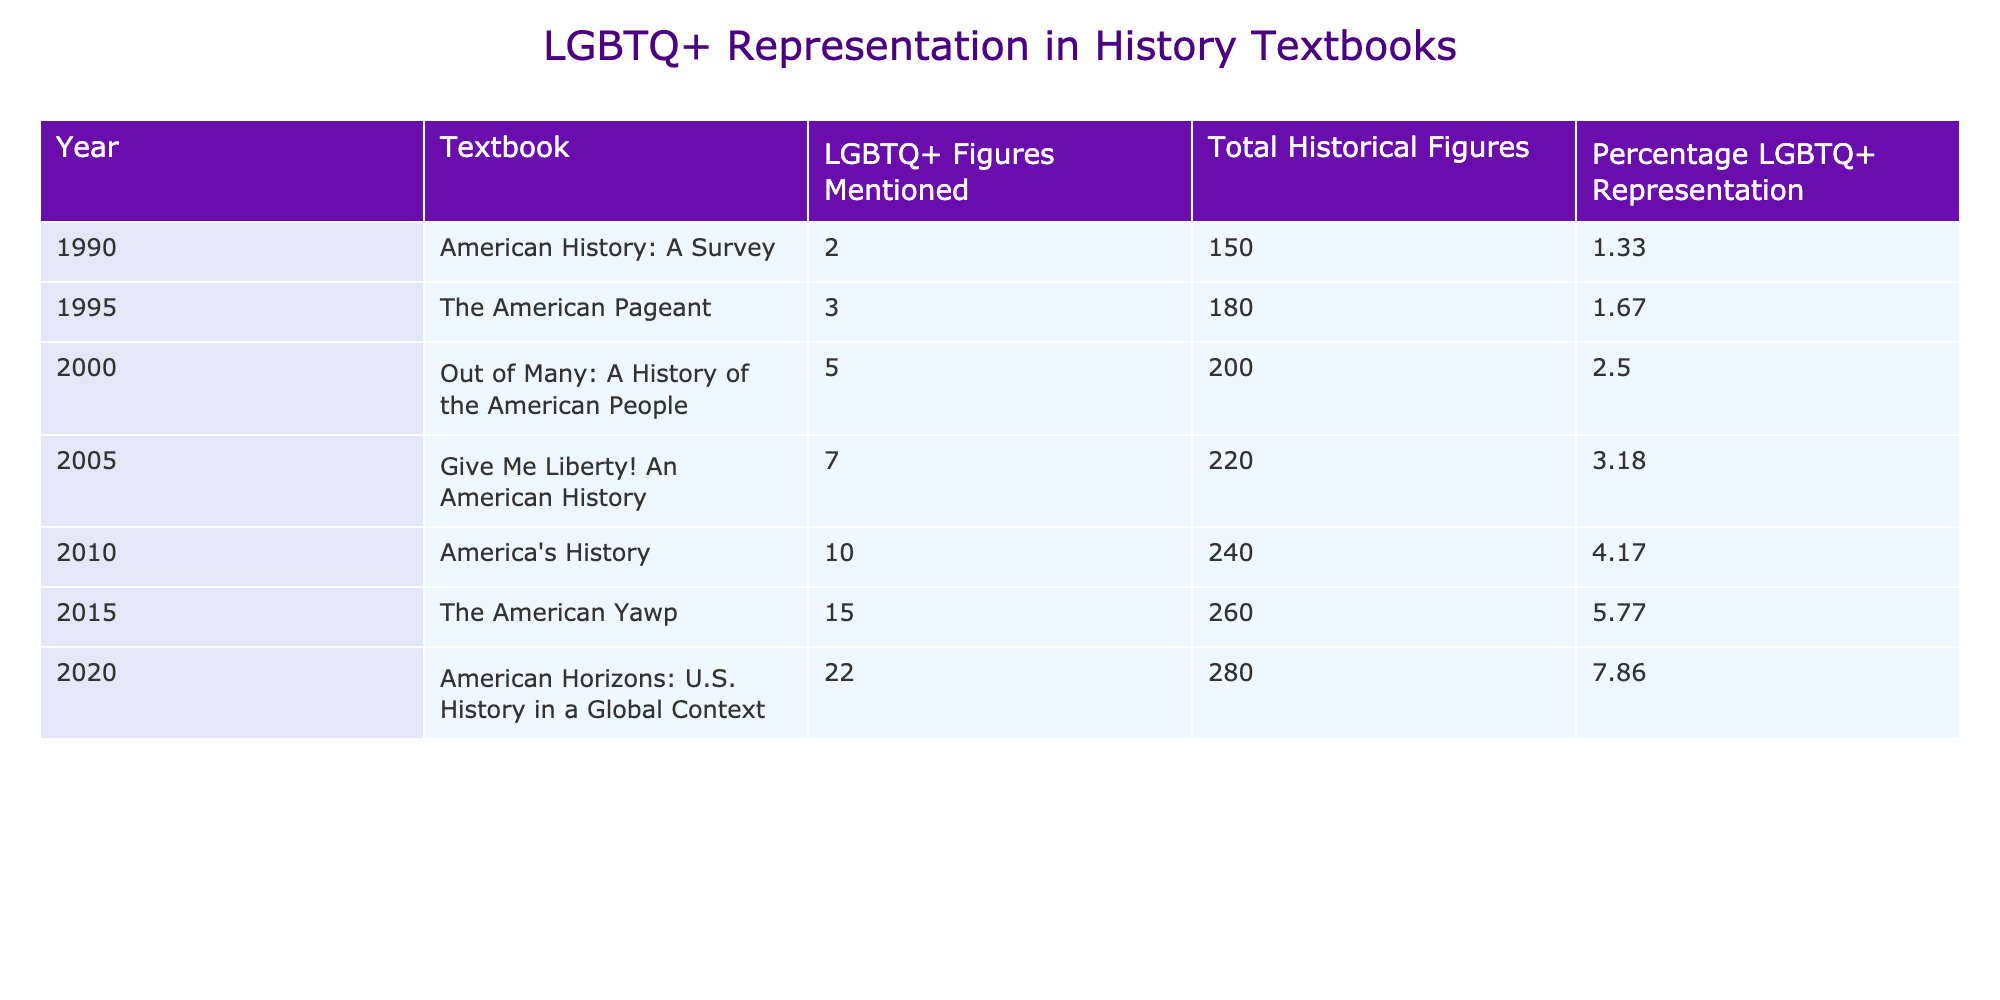What was the percentage of LGBTQ+ representation in the year 2010? According to the table, the Percentage LGBTQ+ Representation for the year 2010 is explicitly listed as 4.17%.
Answer: 4.17% How many LGBTQ+ figures were mentioned in the textbook from the year 2000? The number of LGBTQ+ Figures Mentioned for the year 2000 is directly provided in the table, which states there were 5 figures mentioned.
Answer: 5 What is the total number of historical figures mentioned in the textbook from 2015? From the table, the Total Historical Figures for the year 2015 is noted as 260.
Answer: 260 Which textbook had the highest percentage of LGBTQ+ representation? By comparing the Percentage LGBTQ+ Representation across all the years listed, the highest value is 7.86% in the year 2020, thus that textbook is "American Horizons: U.S. History in a Global Context."
Answer: American Horizons: U.S. History in a Global Context If we consider the years 1990 and 2020, how much did the percentage of LGBTQ+ representation increase? The percentage in 1990 was 1.33% and in 2020 it was 7.86%. The increase is calculated by subtracting: 7.86% - 1.33% = 6.53%.
Answer: 6.53% How many more LGBTQ+ figures were mentioned in 2015 compared to 1990? In 2015, 15 LGBTQ+ figures were mentioned and in 1990, there were 2. The difference is calculated as: 15 - 2 = 13.
Answer: 13 What is the average percentage of LGBTQ+ representation from the years 1990 to 2020? To find the average, add all the percentages: (1.33 + 1.67 + 2.50 + 3.18 + 4.17 + 5.77 + 7.86) = 26.38. Then divide by the number of years (7): 26.38 / 7 = ~3.77.
Answer: ~3.77 Which year showed the largest growth in the number of LGBTQ+ figures mentioned? By analyzing the differences in LGBTQ+ figures mentioned year over year, the largest growth was from 2015 (15 figures) to 2020 (22 figures), which is an increase of 7 figures.
Answer: 2015 to 2020 Is the percentage of LGBTQ+ representation in 2005 greater than the average percentage from 1990 to 2000? The average percentage from 1990 (1.33%) to 2000 (2.50%) is (1.33 + 1.67 + 2.50)/3 = 1.83%. The percentage in 2005 is 3.18%, which is greater than 1.83%.
Answer: Yes If we wanted to see a trend in LGBTQ+ representation over the years, how many years saw an increase in representation compared to the previous year? By examining the data, from 1990 to 2020, every year increased in LGBTQ+ representation compared to the previous year except 1990, resulting in a total of 6 years with increases.
Answer: 6 